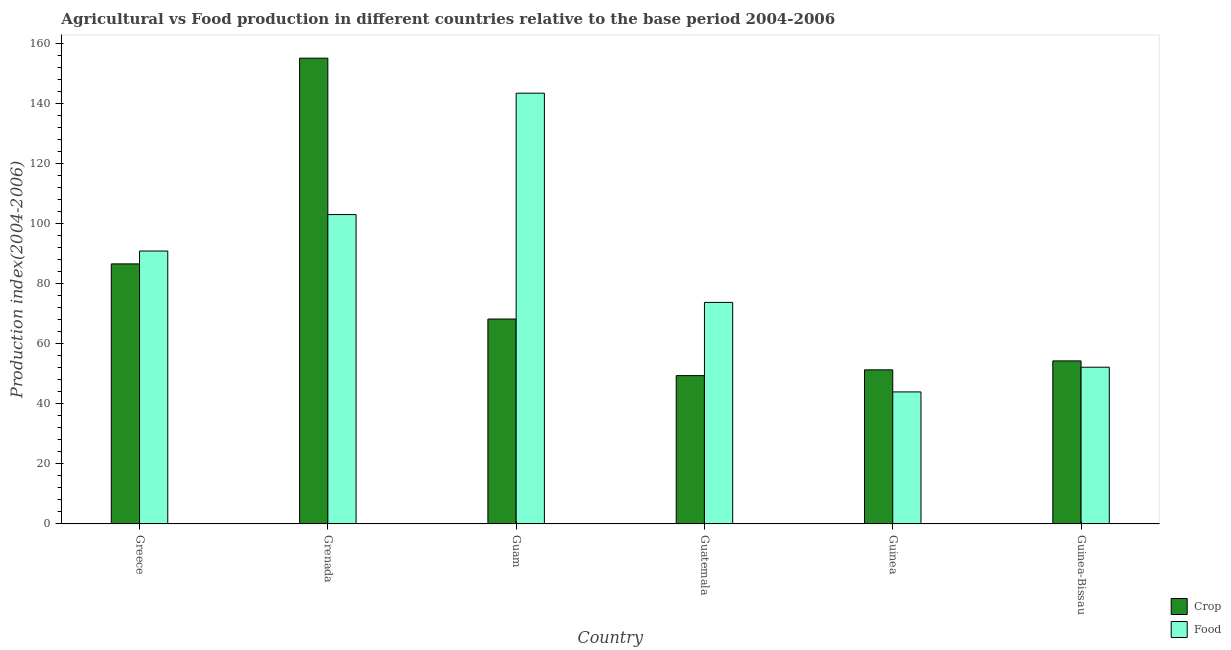How many different coloured bars are there?
Your response must be concise. 2. Are the number of bars on each tick of the X-axis equal?
Make the answer very short. Yes. How many bars are there on the 1st tick from the left?
Your answer should be compact. 2. What is the label of the 1st group of bars from the left?
Give a very brief answer. Greece. What is the food production index in Guinea?
Your answer should be very brief. 43.99. Across all countries, what is the maximum food production index?
Give a very brief answer. 143.49. Across all countries, what is the minimum food production index?
Keep it short and to the point. 43.99. In which country was the food production index maximum?
Make the answer very short. Guam. In which country was the crop production index minimum?
Offer a terse response. Guatemala. What is the total food production index in the graph?
Your answer should be compact. 507.48. What is the difference between the crop production index in Greece and that in Guam?
Offer a terse response. 18.36. What is the difference between the crop production index in Guinea-Bissau and the food production index in Greece?
Offer a very short reply. -36.6. What is the average crop production index per country?
Provide a short and direct response. 77.52. What is the difference between the food production index and crop production index in Guam?
Provide a succinct answer. 75.22. In how many countries, is the crop production index greater than 140 ?
Give a very brief answer. 1. What is the ratio of the food production index in Grenada to that in Guam?
Provide a succinct answer. 0.72. Is the difference between the food production index in Guatemala and Guinea greater than the difference between the crop production index in Guatemala and Guinea?
Your answer should be compact. Yes. What is the difference between the highest and the second highest food production index?
Your answer should be compact. 40.43. What is the difference between the highest and the lowest crop production index?
Offer a very short reply. 105.74. In how many countries, is the crop production index greater than the average crop production index taken over all countries?
Your answer should be compact. 2. Is the sum of the crop production index in Grenada and Guinea greater than the maximum food production index across all countries?
Give a very brief answer. Yes. What does the 2nd bar from the left in Greece represents?
Make the answer very short. Food. What does the 1st bar from the right in Greece represents?
Your response must be concise. Food. How many bars are there?
Offer a very short reply. 12. Are all the bars in the graph horizontal?
Your answer should be very brief. No. How many countries are there in the graph?
Ensure brevity in your answer.  6. Are the values on the major ticks of Y-axis written in scientific E-notation?
Give a very brief answer. No. Does the graph contain grids?
Your response must be concise. No. Where does the legend appear in the graph?
Your answer should be very brief. Bottom right. How many legend labels are there?
Offer a terse response. 2. How are the legend labels stacked?
Make the answer very short. Vertical. What is the title of the graph?
Your answer should be very brief. Agricultural vs Food production in different countries relative to the base period 2004-2006. Does "Quasi money growth" appear as one of the legend labels in the graph?
Provide a short and direct response. No. What is the label or title of the X-axis?
Ensure brevity in your answer.  Country. What is the label or title of the Y-axis?
Your answer should be very brief. Production index(2004-2006). What is the Production index(2004-2006) of Crop in Greece?
Your response must be concise. 86.63. What is the Production index(2004-2006) in Food in Greece?
Give a very brief answer. 90.92. What is the Production index(2004-2006) of Crop in Grenada?
Offer a terse response. 155.16. What is the Production index(2004-2006) in Food in Grenada?
Offer a terse response. 103.06. What is the Production index(2004-2006) in Crop in Guam?
Provide a short and direct response. 68.27. What is the Production index(2004-2006) of Food in Guam?
Ensure brevity in your answer.  143.49. What is the Production index(2004-2006) in Crop in Guatemala?
Offer a terse response. 49.42. What is the Production index(2004-2006) in Food in Guatemala?
Your response must be concise. 73.8. What is the Production index(2004-2006) of Crop in Guinea?
Ensure brevity in your answer.  51.34. What is the Production index(2004-2006) of Food in Guinea?
Your answer should be very brief. 43.99. What is the Production index(2004-2006) in Crop in Guinea-Bissau?
Your answer should be compact. 54.32. What is the Production index(2004-2006) in Food in Guinea-Bissau?
Your answer should be compact. 52.22. Across all countries, what is the maximum Production index(2004-2006) in Crop?
Your answer should be compact. 155.16. Across all countries, what is the maximum Production index(2004-2006) in Food?
Keep it short and to the point. 143.49. Across all countries, what is the minimum Production index(2004-2006) of Crop?
Offer a terse response. 49.42. Across all countries, what is the minimum Production index(2004-2006) in Food?
Ensure brevity in your answer.  43.99. What is the total Production index(2004-2006) in Crop in the graph?
Offer a terse response. 465.14. What is the total Production index(2004-2006) in Food in the graph?
Ensure brevity in your answer.  507.48. What is the difference between the Production index(2004-2006) of Crop in Greece and that in Grenada?
Ensure brevity in your answer.  -68.53. What is the difference between the Production index(2004-2006) in Food in Greece and that in Grenada?
Your response must be concise. -12.14. What is the difference between the Production index(2004-2006) in Crop in Greece and that in Guam?
Your response must be concise. 18.36. What is the difference between the Production index(2004-2006) of Food in Greece and that in Guam?
Your answer should be very brief. -52.57. What is the difference between the Production index(2004-2006) of Crop in Greece and that in Guatemala?
Ensure brevity in your answer.  37.21. What is the difference between the Production index(2004-2006) in Food in Greece and that in Guatemala?
Your answer should be compact. 17.12. What is the difference between the Production index(2004-2006) in Crop in Greece and that in Guinea?
Make the answer very short. 35.29. What is the difference between the Production index(2004-2006) of Food in Greece and that in Guinea?
Keep it short and to the point. 46.93. What is the difference between the Production index(2004-2006) of Crop in Greece and that in Guinea-Bissau?
Ensure brevity in your answer.  32.31. What is the difference between the Production index(2004-2006) in Food in Greece and that in Guinea-Bissau?
Keep it short and to the point. 38.7. What is the difference between the Production index(2004-2006) of Crop in Grenada and that in Guam?
Offer a very short reply. 86.89. What is the difference between the Production index(2004-2006) of Food in Grenada and that in Guam?
Your response must be concise. -40.43. What is the difference between the Production index(2004-2006) in Crop in Grenada and that in Guatemala?
Give a very brief answer. 105.74. What is the difference between the Production index(2004-2006) in Food in Grenada and that in Guatemala?
Offer a very short reply. 29.26. What is the difference between the Production index(2004-2006) in Crop in Grenada and that in Guinea?
Provide a short and direct response. 103.82. What is the difference between the Production index(2004-2006) in Food in Grenada and that in Guinea?
Offer a terse response. 59.07. What is the difference between the Production index(2004-2006) of Crop in Grenada and that in Guinea-Bissau?
Your response must be concise. 100.84. What is the difference between the Production index(2004-2006) in Food in Grenada and that in Guinea-Bissau?
Ensure brevity in your answer.  50.84. What is the difference between the Production index(2004-2006) of Crop in Guam and that in Guatemala?
Your answer should be compact. 18.85. What is the difference between the Production index(2004-2006) in Food in Guam and that in Guatemala?
Your answer should be very brief. 69.69. What is the difference between the Production index(2004-2006) in Crop in Guam and that in Guinea?
Give a very brief answer. 16.93. What is the difference between the Production index(2004-2006) in Food in Guam and that in Guinea?
Keep it short and to the point. 99.5. What is the difference between the Production index(2004-2006) of Crop in Guam and that in Guinea-Bissau?
Keep it short and to the point. 13.95. What is the difference between the Production index(2004-2006) of Food in Guam and that in Guinea-Bissau?
Offer a very short reply. 91.27. What is the difference between the Production index(2004-2006) of Crop in Guatemala and that in Guinea?
Make the answer very short. -1.92. What is the difference between the Production index(2004-2006) of Food in Guatemala and that in Guinea?
Your answer should be compact. 29.81. What is the difference between the Production index(2004-2006) of Crop in Guatemala and that in Guinea-Bissau?
Your answer should be compact. -4.9. What is the difference between the Production index(2004-2006) in Food in Guatemala and that in Guinea-Bissau?
Keep it short and to the point. 21.58. What is the difference between the Production index(2004-2006) of Crop in Guinea and that in Guinea-Bissau?
Your answer should be compact. -2.98. What is the difference between the Production index(2004-2006) in Food in Guinea and that in Guinea-Bissau?
Your response must be concise. -8.23. What is the difference between the Production index(2004-2006) of Crop in Greece and the Production index(2004-2006) of Food in Grenada?
Provide a succinct answer. -16.43. What is the difference between the Production index(2004-2006) of Crop in Greece and the Production index(2004-2006) of Food in Guam?
Ensure brevity in your answer.  -56.86. What is the difference between the Production index(2004-2006) in Crop in Greece and the Production index(2004-2006) in Food in Guatemala?
Make the answer very short. 12.83. What is the difference between the Production index(2004-2006) of Crop in Greece and the Production index(2004-2006) of Food in Guinea?
Make the answer very short. 42.64. What is the difference between the Production index(2004-2006) of Crop in Greece and the Production index(2004-2006) of Food in Guinea-Bissau?
Give a very brief answer. 34.41. What is the difference between the Production index(2004-2006) in Crop in Grenada and the Production index(2004-2006) in Food in Guam?
Provide a short and direct response. 11.67. What is the difference between the Production index(2004-2006) of Crop in Grenada and the Production index(2004-2006) of Food in Guatemala?
Make the answer very short. 81.36. What is the difference between the Production index(2004-2006) in Crop in Grenada and the Production index(2004-2006) in Food in Guinea?
Ensure brevity in your answer.  111.17. What is the difference between the Production index(2004-2006) in Crop in Grenada and the Production index(2004-2006) in Food in Guinea-Bissau?
Your answer should be compact. 102.94. What is the difference between the Production index(2004-2006) of Crop in Guam and the Production index(2004-2006) of Food in Guatemala?
Offer a terse response. -5.53. What is the difference between the Production index(2004-2006) of Crop in Guam and the Production index(2004-2006) of Food in Guinea?
Offer a very short reply. 24.28. What is the difference between the Production index(2004-2006) of Crop in Guam and the Production index(2004-2006) of Food in Guinea-Bissau?
Your answer should be compact. 16.05. What is the difference between the Production index(2004-2006) in Crop in Guatemala and the Production index(2004-2006) in Food in Guinea?
Your response must be concise. 5.43. What is the difference between the Production index(2004-2006) of Crop in Guinea and the Production index(2004-2006) of Food in Guinea-Bissau?
Give a very brief answer. -0.88. What is the average Production index(2004-2006) of Crop per country?
Make the answer very short. 77.52. What is the average Production index(2004-2006) in Food per country?
Provide a succinct answer. 84.58. What is the difference between the Production index(2004-2006) in Crop and Production index(2004-2006) in Food in Greece?
Provide a short and direct response. -4.29. What is the difference between the Production index(2004-2006) of Crop and Production index(2004-2006) of Food in Grenada?
Your answer should be compact. 52.1. What is the difference between the Production index(2004-2006) in Crop and Production index(2004-2006) in Food in Guam?
Ensure brevity in your answer.  -75.22. What is the difference between the Production index(2004-2006) of Crop and Production index(2004-2006) of Food in Guatemala?
Provide a short and direct response. -24.38. What is the difference between the Production index(2004-2006) of Crop and Production index(2004-2006) of Food in Guinea?
Provide a succinct answer. 7.35. What is the ratio of the Production index(2004-2006) in Crop in Greece to that in Grenada?
Give a very brief answer. 0.56. What is the ratio of the Production index(2004-2006) of Food in Greece to that in Grenada?
Your answer should be very brief. 0.88. What is the ratio of the Production index(2004-2006) in Crop in Greece to that in Guam?
Offer a terse response. 1.27. What is the ratio of the Production index(2004-2006) of Food in Greece to that in Guam?
Keep it short and to the point. 0.63. What is the ratio of the Production index(2004-2006) in Crop in Greece to that in Guatemala?
Your response must be concise. 1.75. What is the ratio of the Production index(2004-2006) in Food in Greece to that in Guatemala?
Provide a succinct answer. 1.23. What is the ratio of the Production index(2004-2006) of Crop in Greece to that in Guinea?
Keep it short and to the point. 1.69. What is the ratio of the Production index(2004-2006) of Food in Greece to that in Guinea?
Your response must be concise. 2.07. What is the ratio of the Production index(2004-2006) in Crop in Greece to that in Guinea-Bissau?
Ensure brevity in your answer.  1.59. What is the ratio of the Production index(2004-2006) of Food in Greece to that in Guinea-Bissau?
Your answer should be compact. 1.74. What is the ratio of the Production index(2004-2006) in Crop in Grenada to that in Guam?
Give a very brief answer. 2.27. What is the ratio of the Production index(2004-2006) of Food in Grenada to that in Guam?
Your answer should be compact. 0.72. What is the ratio of the Production index(2004-2006) of Crop in Grenada to that in Guatemala?
Ensure brevity in your answer.  3.14. What is the ratio of the Production index(2004-2006) of Food in Grenada to that in Guatemala?
Give a very brief answer. 1.4. What is the ratio of the Production index(2004-2006) of Crop in Grenada to that in Guinea?
Ensure brevity in your answer.  3.02. What is the ratio of the Production index(2004-2006) in Food in Grenada to that in Guinea?
Keep it short and to the point. 2.34. What is the ratio of the Production index(2004-2006) in Crop in Grenada to that in Guinea-Bissau?
Keep it short and to the point. 2.86. What is the ratio of the Production index(2004-2006) in Food in Grenada to that in Guinea-Bissau?
Offer a terse response. 1.97. What is the ratio of the Production index(2004-2006) of Crop in Guam to that in Guatemala?
Your answer should be compact. 1.38. What is the ratio of the Production index(2004-2006) of Food in Guam to that in Guatemala?
Ensure brevity in your answer.  1.94. What is the ratio of the Production index(2004-2006) of Crop in Guam to that in Guinea?
Your answer should be very brief. 1.33. What is the ratio of the Production index(2004-2006) of Food in Guam to that in Guinea?
Your answer should be compact. 3.26. What is the ratio of the Production index(2004-2006) in Crop in Guam to that in Guinea-Bissau?
Your answer should be very brief. 1.26. What is the ratio of the Production index(2004-2006) in Food in Guam to that in Guinea-Bissau?
Give a very brief answer. 2.75. What is the ratio of the Production index(2004-2006) in Crop in Guatemala to that in Guinea?
Provide a short and direct response. 0.96. What is the ratio of the Production index(2004-2006) of Food in Guatemala to that in Guinea?
Provide a succinct answer. 1.68. What is the ratio of the Production index(2004-2006) in Crop in Guatemala to that in Guinea-Bissau?
Offer a terse response. 0.91. What is the ratio of the Production index(2004-2006) of Food in Guatemala to that in Guinea-Bissau?
Provide a succinct answer. 1.41. What is the ratio of the Production index(2004-2006) of Crop in Guinea to that in Guinea-Bissau?
Your response must be concise. 0.95. What is the ratio of the Production index(2004-2006) of Food in Guinea to that in Guinea-Bissau?
Keep it short and to the point. 0.84. What is the difference between the highest and the second highest Production index(2004-2006) of Crop?
Offer a terse response. 68.53. What is the difference between the highest and the second highest Production index(2004-2006) of Food?
Your answer should be compact. 40.43. What is the difference between the highest and the lowest Production index(2004-2006) of Crop?
Your answer should be very brief. 105.74. What is the difference between the highest and the lowest Production index(2004-2006) in Food?
Provide a succinct answer. 99.5. 